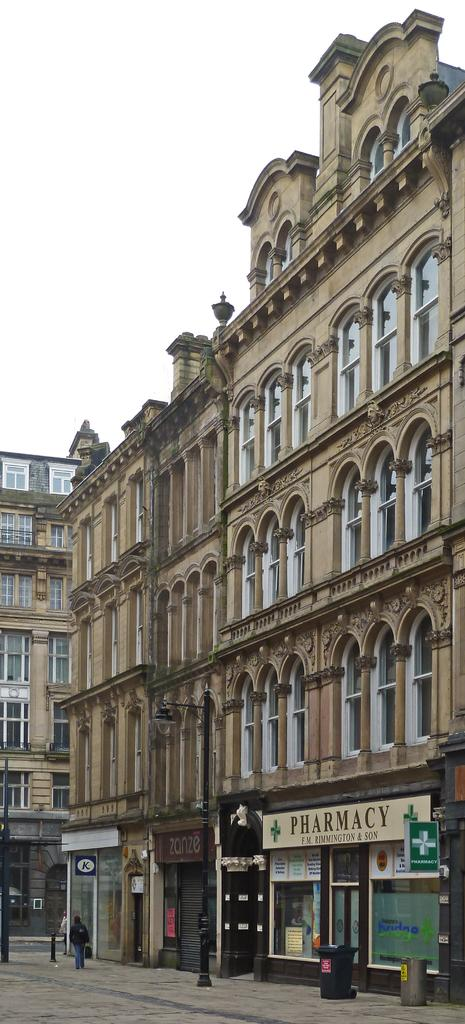What type of structures can be seen in the image? There are buildings in the image. What else can be found in the image besides buildings? There are stalls in the image. Can you describe the activity of a person in the image? There is a person walking on the pavement in the image. Where is the robin perched on the branch in the image? There is no robin or branch present in the image. 